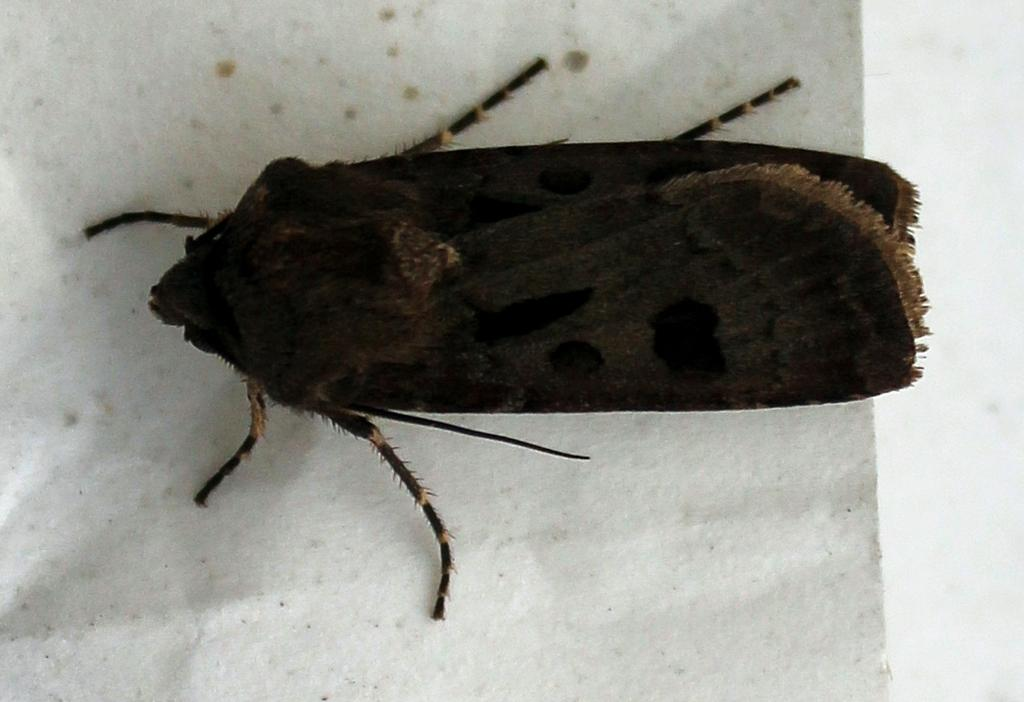What type of creature can be seen in the image? There is an insect in the image. What type of dress is the insect wearing in the image? Insects do not wear dresses, as they are not human and do not have the ability to wear clothing. 